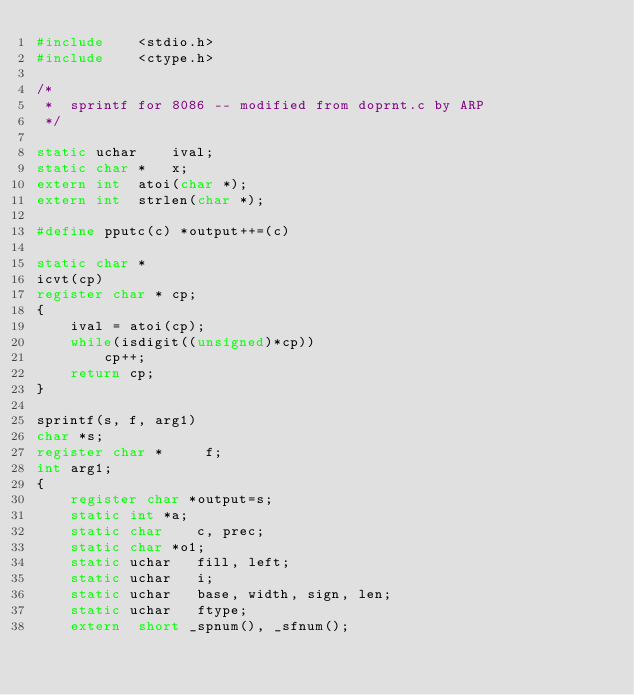Convert code to text. <code><loc_0><loc_0><loc_500><loc_500><_C_>#include	<stdio.h>
#include	<ctype.h>

/*
 *  sprintf for 8086 -- modified from doprnt.c by ARP
 */

static uchar	ival;
static char *	x;
extern int	atoi(char *);
extern int	strlen(char *);

#define pputc(c) *output++=(c)

static char *
icvt(cp)
register char *	cp;
{
	ival = atoi(cp);
	while(isdigit((unsigned)*cp))
		cp++;
	return cp;
}

sprintf(s, f, arg1)
char *s;
register char *     f;
int arg1;
{
    register char *output=s;
    static int *a;
    static char    c, prec;
    static char *o1;
    static uchar   fill, left;
    static uchar   i;
    static uchar   base, width, sign, len;
    static uchar   ftype;
    extern  short _spnum(), _sfnum();
</code> 